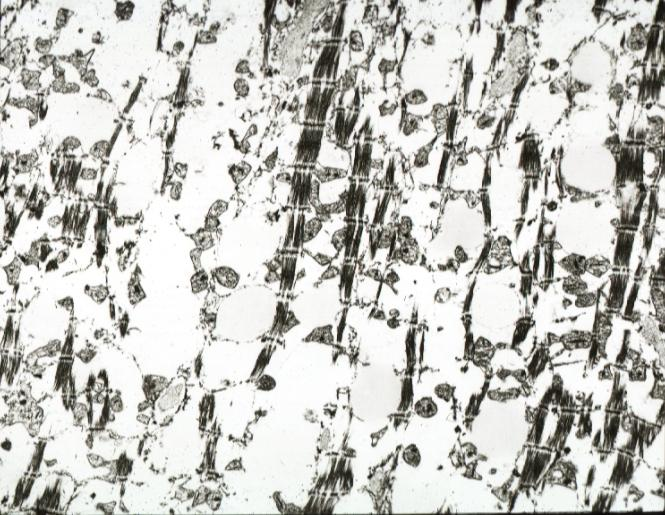s cardiovascular present?
Answer the question using a single word or phrase. Yes 